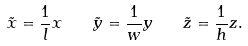Convert formula to latex. <formula><loc_0><loc_0><loc_500><loc_500>\tilde { x } = \frac { 1 } { l } x \quad \tilde { y } = \frac { 1 } { w } y \quad \tilde { z } = \frac { 1 } { h } z .</formula> 